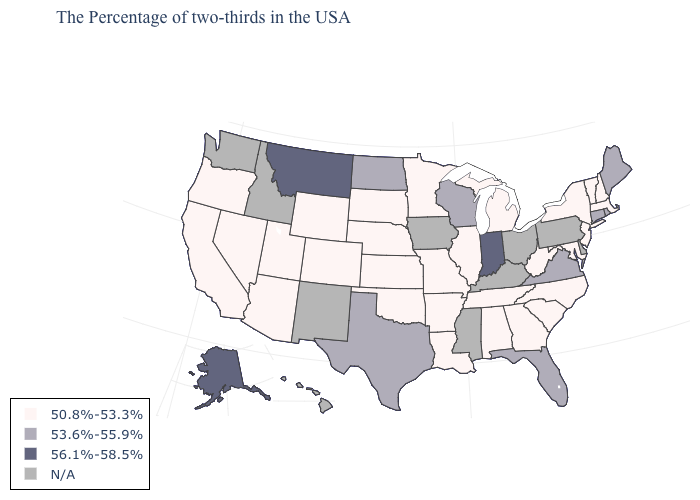Which states hav the highest value in the West?
Quick response, please. Montana, Alaska. What is the value of New York?
Keep it brief. 50.8%-53.3%. Name the states that have a value in the range 50.8%-53.3%?
Answer briefly. Massachusetts, New Hampshire, Vermont, New York, New Jersey, Maryland, North Carolina, South Carolina, West Virginia, Georgia, Michigan, Alabama, Tennessee, Illinois, Louisiana, Missouri, Arkansas, Minnesota, Kansas, Nebraska, Oklahoma, South Dakota, Wyoming, Colorado, Utah, Arizona, Nevada, California, Oregon. Name the states that have a value in the range 53.6%-55.9%?
Short answer required. Maine, Rhode Island, Connecticut, Virginia, Florida, Wisconsin, Texas, North Dakota. What is the lowest value in states that border Iowa?
Concise answer only. 50.8%-53.3%. Name the states that have a value in the range 56.1%-58.5%?
Concise answer only. Indiana, Montana, Alaska. Name the states that have a value in the range N/A?
Give a very brief answer. Delaware, Pennsylvania, Ohio, Kentucky, Mississippi, Iowa, New Mexico, Idaho, Washington, Hawaii. Which states have the lowest value in the South?
Keep it brief. Maryland, North Carolina, South Carolina, West Virginia, Georgia, Alabama, Tennessee, Louisiana, Arkansas, Oklahoma. Name the states that have a value in the range 50.8%-53.3%?
Quick response, please. Massachusetts, New Hampshire, Vermont, New York, New Jersey, Maryland, North Carolina, South Carolina, West Virginia, Georgia, Michigan, Alabama, Tennessee, Illinois, Louisiana, Missouri, Arkansas, Minnesota, Kansas, Nebraska, Oklahoma, South Dakota, Wyoming, Colorado, Utah, Arizona, Nevada, California, Oregon. Which states have the highest value in the USA?
Give a very brief answer. Indiana, Montana, Alaska. Name the states that have a value in the range 56.1%-58.5%?
Answer briefly. Indiana, Montana, Alaska. What is the value of Arkansas?
Give a very brief answer. 50.8%-53.3%. 